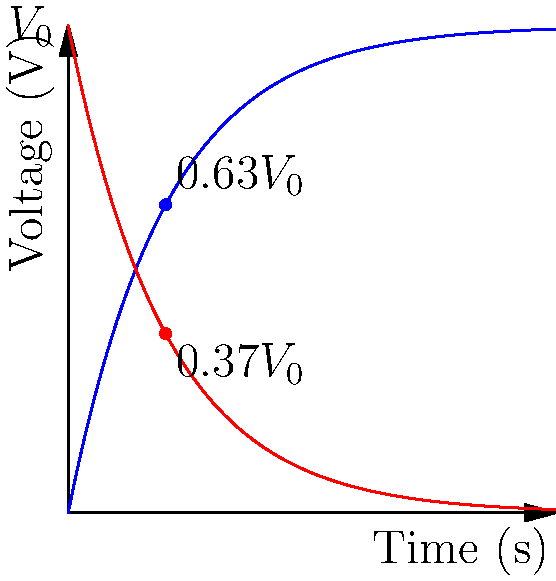In the RC circuit shown above, the capacitor is charged and discharged through a resistor. The time constant $\tau$ is 1 second, and the initial voltage $V_0$ is 5V. After one time constant during the charging process, what percentage of the initial voltage has the capacitor reached? Express your answer as a percentage rounded to the nearest whole number. Let's approach this step-by-step:

1) The charging equation for a capacitor in an RC circuit is:
   $V(t) = V_0(1 - e^{-t/\tau})$

2) We're asked about the voltage after one time constant, so $t = \tau$:
   $V(\tau) = V_0(1 - e^{-\tau/\tau}) = V_0(1 - e^{-1})$

3) Let's calculate this:
   $V(\tau) = V_0(1 - e^{-1}) = V_0(1 - 0.368) = 0.632V_0$

4) This means after one time constant, the capacitor has reached 63.2% of the initial voltage.

5) Rounding to the nearest whole number:
   63.2% ≈ 63%

This result is a fundamental principle in RC circuits: after one time constant, the capacitor charges to approximately 63% of its final voltage.
Answer: 63% 